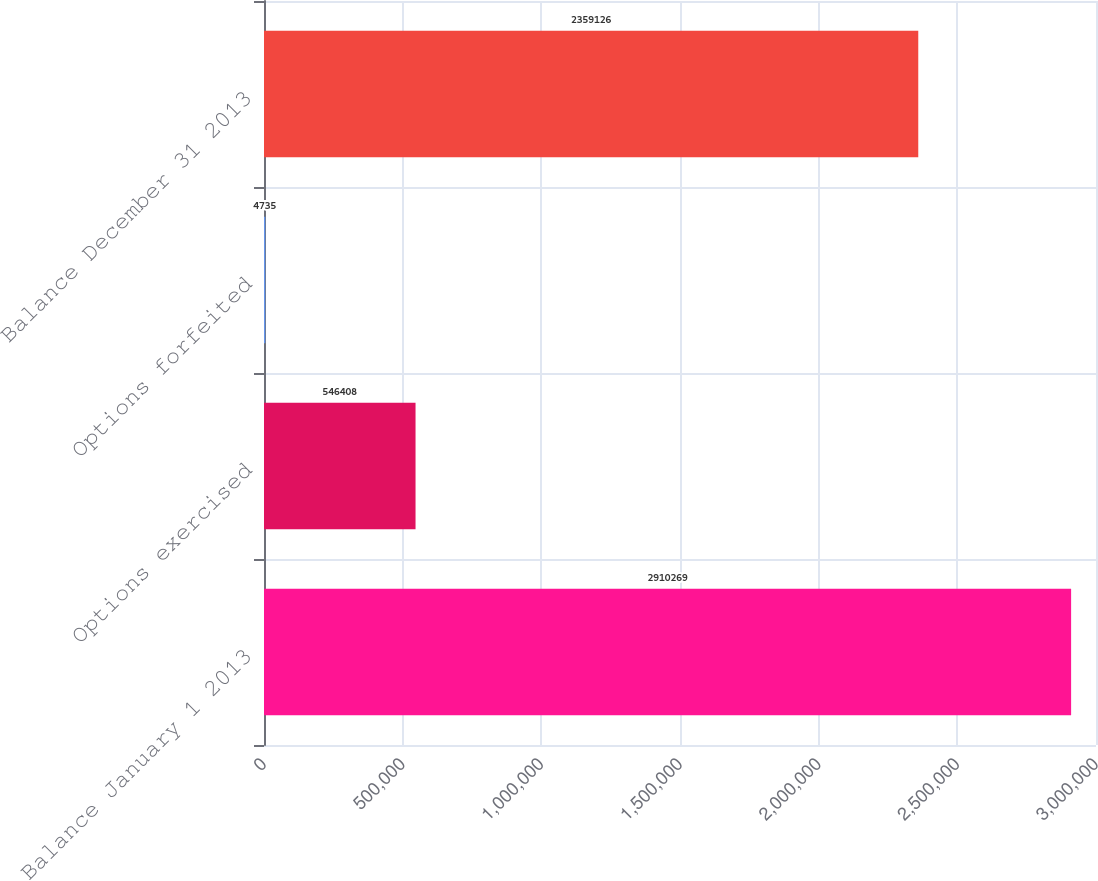Convert chart to OTSL. <chart><loc_0><loc_0><loc_500><loc_500><bar_chart><fcel>Balance January 1 2013<fcel>Options exercised<fcel>Options forfeited<fcel>Balance December 31 2013<nl><fcel>2.91027e+06<fcel>546408<fcel>4735<fcel>2.35913e+06<nl></chart> 